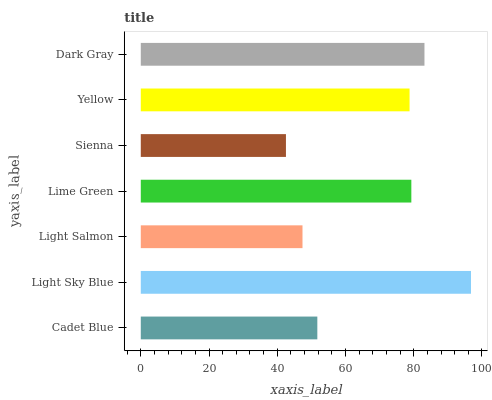Is Sienna the minimum?
Answer yes or no. Yes. Is Light Sky Blue the maximum?
Answer yes or no. Yes. Is Light Salmon the minimum?
Answer yes or no. No. Is Light Salmon the maximum?
Answer yes or no. No. Is Light Sky Blue greater than Light Salmon?
Answer yes or no. Yes. Is Light Salmon less than Light Sky Blue?
Answer yes or no. Yes. Is Light Salmon greater than Light Sky Blue?
Answer yes or no. No. Is Light Sky Blue less than Light Salmon?
Answer yes or no. No. Is Yellow the high median?
Answer yes or no. Yes. Is Yellow the low median?
Answer yes or no. Yes. Is Light Salmon the high median?
Answer yes or no. No. Is Light Salmon the low median?
Answer yes or no. No. 